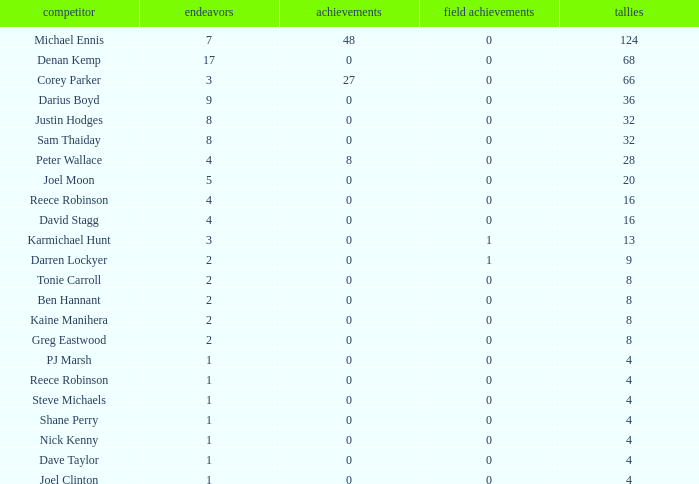What is the total number of field goals of Denan Kemp, who has more than 4 tries, more than 32 points, and 0 goals? 1.0. 